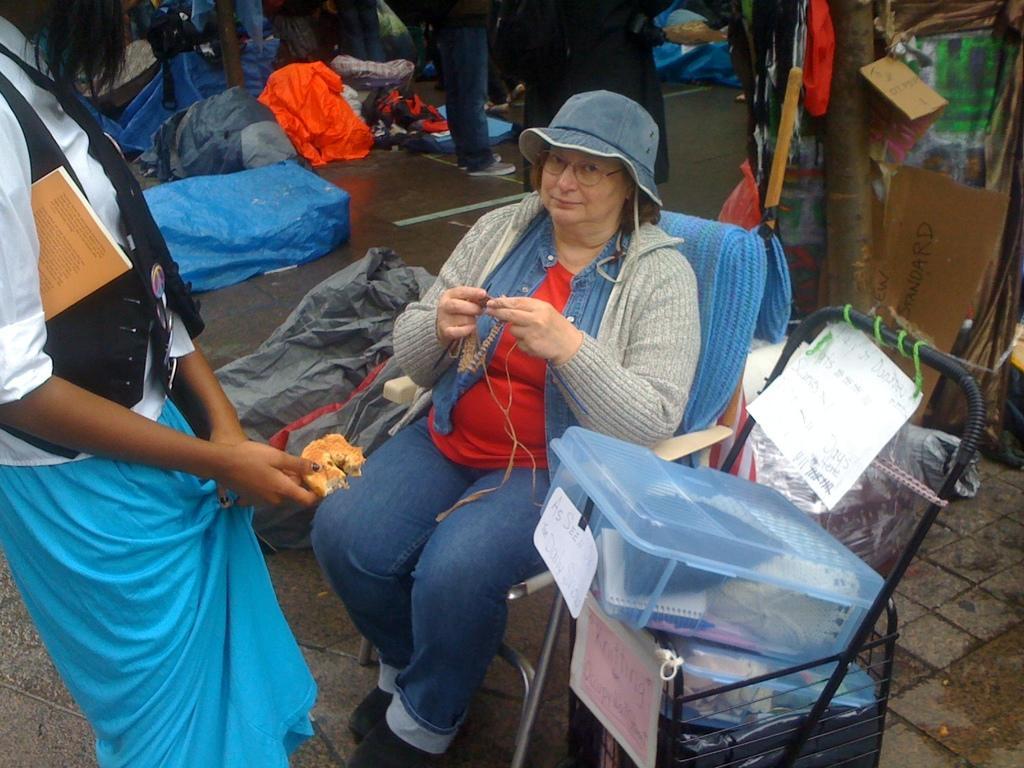How would you summarize this image in a sentence or two? There is a woman is sitting on the chair and looking at the picture. Beside her bags and boxes are placed on the ground. On the left side a person standing and holding some food item in the hand. In the background there are many people standing and also I can see few clothes and bags on the floor. On the right side there is a tree trunk and some objects. 